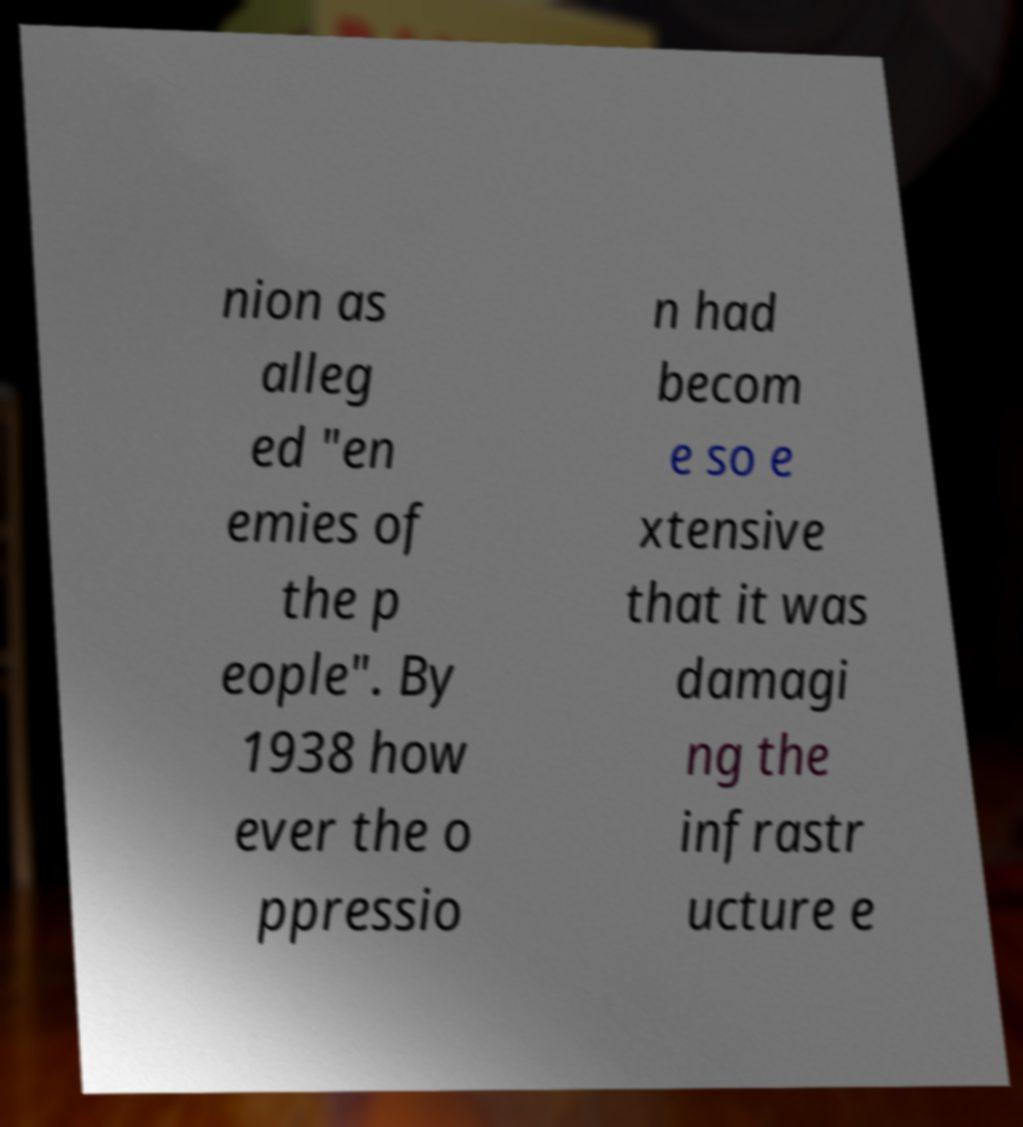Could you assist in decoding the text presented in this image and type it out clearly? nion as alleg ed "en emies of the p eople". By 1938 how ever the o ppressio n had becom e so e xtensive that it was damagi ng the infrastr ucture e 